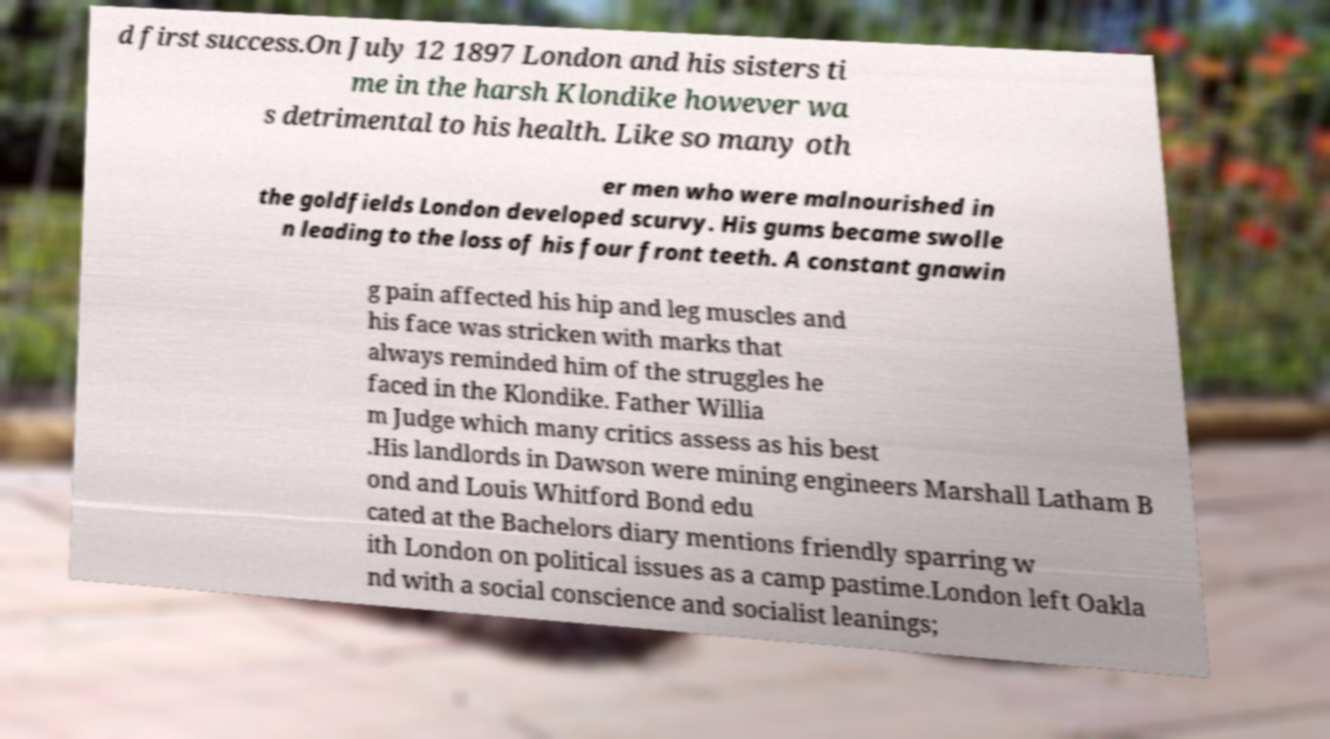I need the written content from this picture converted into text. Can you do that? d first success.On July 12 1897 London and his sisters ti me in the harsh Klondike however wa s detrimental to his health. Like so many oth er men who were malnourished in the goldfields London developed scurvy. His gums became swolle n leading to the loss of his four front teeth. A constant gnawin g pain affected his hip and leg muscles and his face was stricken with marks that always reminded him of the struggles he faced in the Klondike. Father Willia m Judge which many critics assess as his best .His landlords in Dawson were mining engineers Marshall Latham B ond and Louis Whitford Bond edu cated at the Bachelors diary mentions friendly sparring w ith London on political issues as a camp pastime.London left Oakla nd with a social conscience and socialist leanings; 